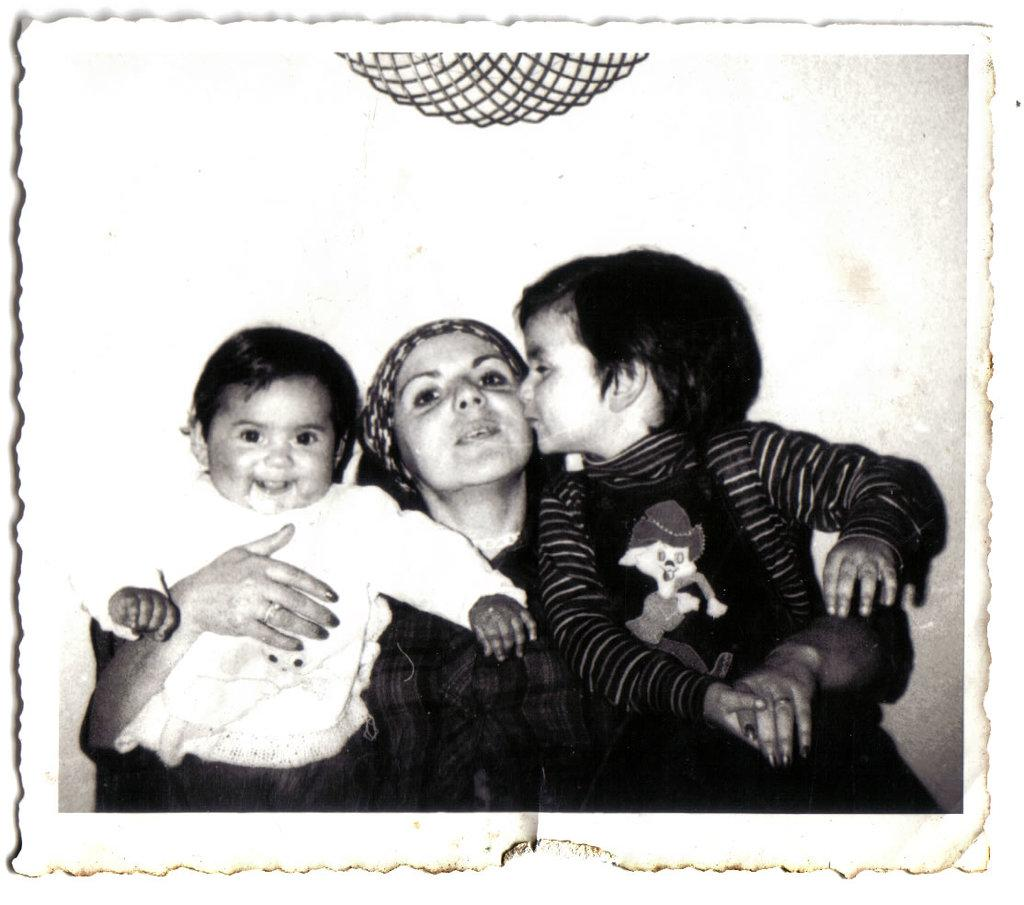Who is the main subject in the image? There is a woman in the image. What is the woman doing in the image? The woman is holding two babies. What is the color scheme of the image? The image is black and white in color. What type of square object can be seen in the image? There is no square object present in the image. What scent is associated with the woman in the image? There is no information about the scent in the image. 